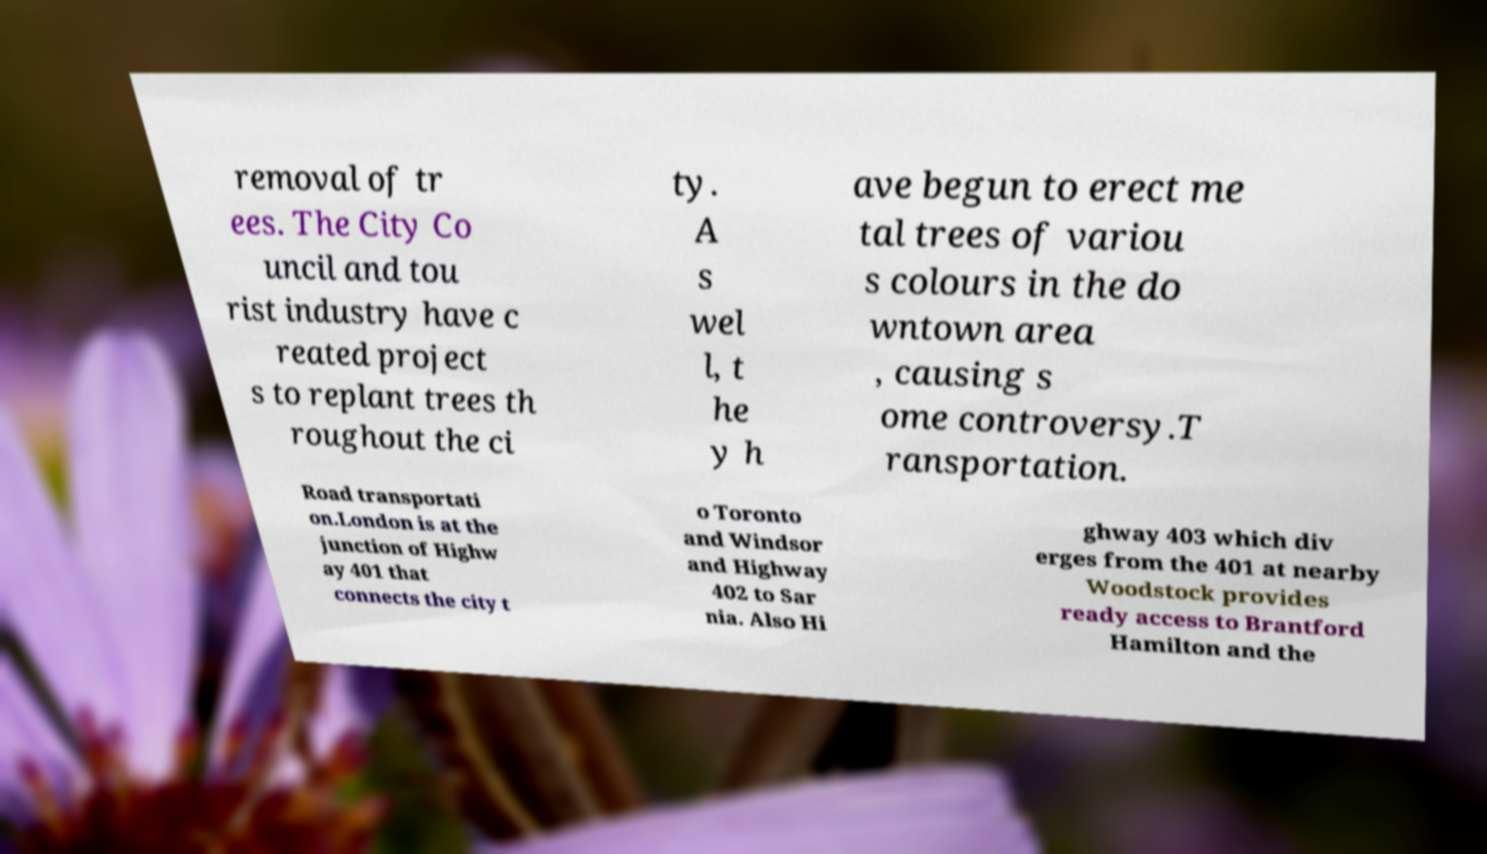For documentation purposes, I need the text within this image transcribed. Could you provide that? removal of tr ees. The City Co uncil and tou rist industry have c reated project s to replant trees th roughout the ci ty. A s wel l, t he y h ave begun to erect me tal trees of variou s colours in the do wntown area , causing s ome controversy.T ransportation. Road transportati on.London is at the junction of Highw ay 401 that connects the city t o Toronto and Windsor and Highway 402 to Sar nia. Also Hi ghway 403 which div erges from the 401 at nearby Woodstock provides ready access to Brantford Hamilton and the 